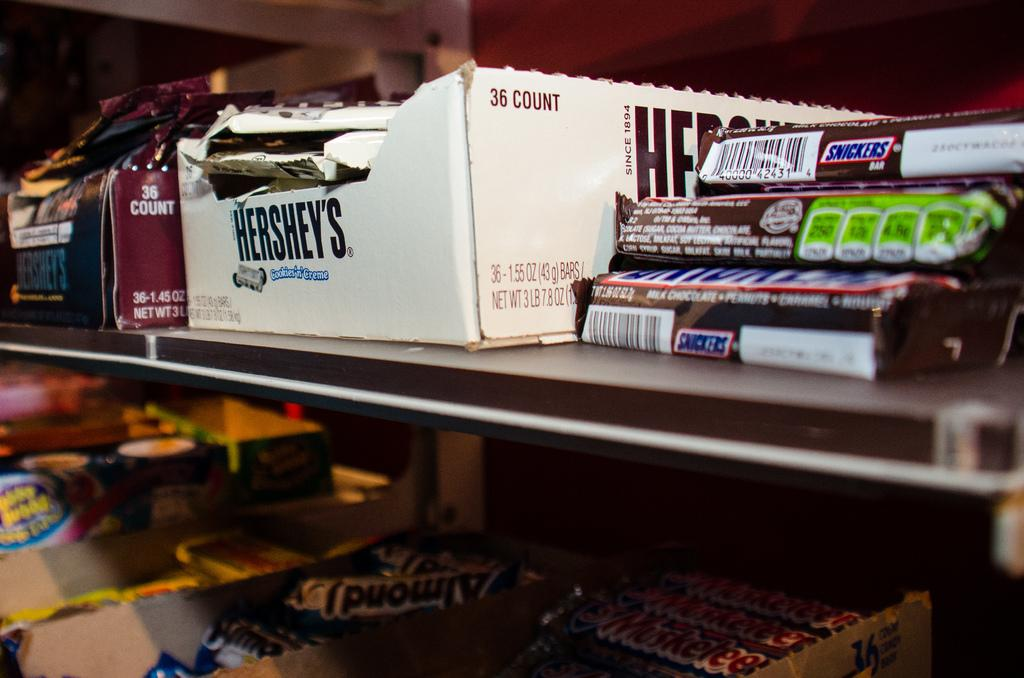<image>
Provide a brief description of the given image. Boxes of candy bars including Hershey's and Snickers. 